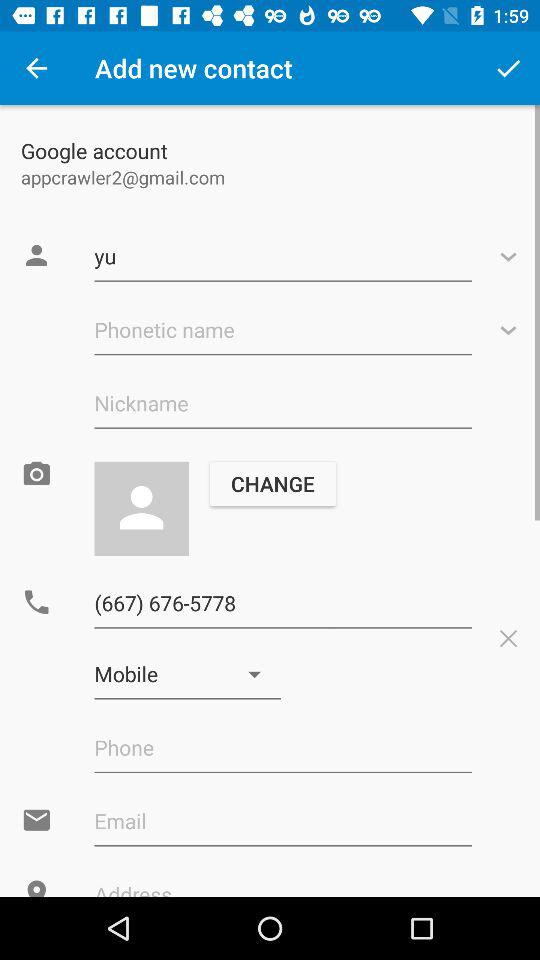What is the email address? The email address is appcrawler2@gmail.com. 